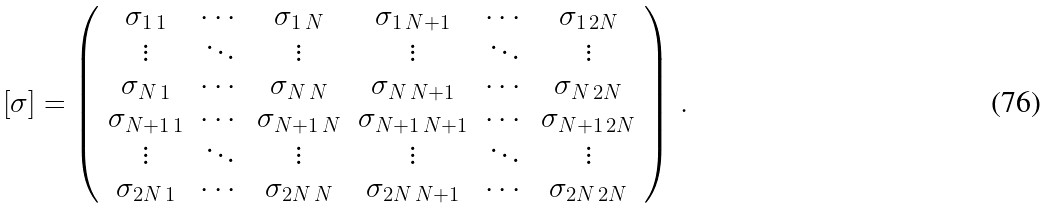<formula> <loc_0><loc_0><loc_500><loc_500>[ \sigma ] = \left ( \begin{array} { c c c c c c } \sigma _ { 1 \, 1 } & \cdots & \sigma _ { 1 \, N } & \sigma _ { 1 \, N + 1 } & \cdots & \sigma _ { 1 \, 2 N } \\ \vdots & \ddots & \vdots & \vdots & \ddots & \vdots \\ \sigma _ { N \, 1 } & \cdots & \sigma _ { N \, N } & \sigma _ { N \, N + 1 } & \cdots & \sigma _ { N \, 2 N } \\ \sigma _ { N + 1 \, 1 } & \cdots & \sigma _ { N + 1 \, N } & \sigma _ { N + 1 \, N + 1 } & \cdots & \sigma _ { N + 1 \, 2 N } \\ \vdots & \ddots & \vdots & \vdots & \ddots & \vdots \\ \sigma _ { 2 N \, 1 } & \cdots & \sigma _ { 2 N \, N } & \sigma _ { 2 N \, N + 1 } & \cdots & \sigma _ { 2 N \, 2 N } \\ \end{array} \right ) \, .</formula> 